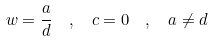<formula> <loc_0><loc_0><loc_500><loc_500>w = \frac { a } { d } \ \ , \ \ c = 0 \ \ , \ \ a \neq d</formula> 